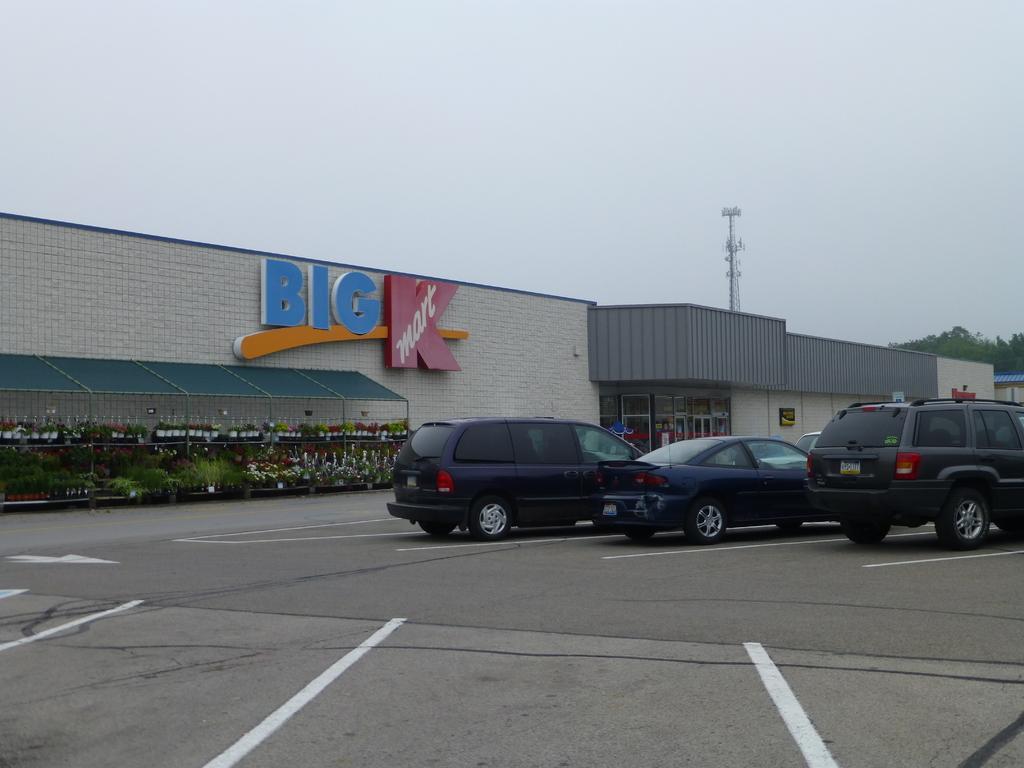Describe this image in one or two sentences. In this image at front cars were parked on the road. At the back side there are plants with the flowers on it. At the background there are buildings, trees, tower and sky. 